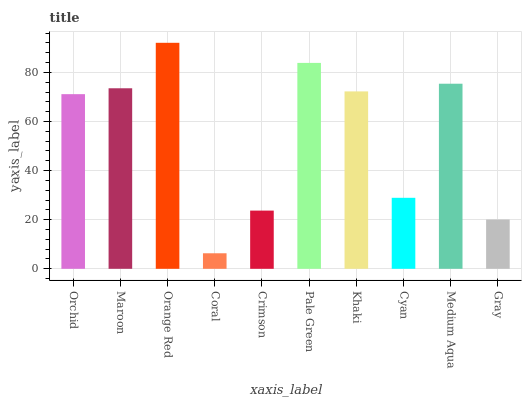Is Coral the minimum?
Answer yes or no. Yes. Is Orange Red the maximum?
Answer yes or no. Yes. Is Maroon the minimum?
Answer yes or no. No. Is Maroon the maximum?
Answer yes or no. No. Is Maroon greater than Orchid?
Answer yes or no. Yes. Is Orchid less than Maroon?
Answer yes or no. Yes. Is Orchid greater than Maroon?
Answer yes or no. No. Is Maroon less than Orchid?
Answer yes or no. No. Is Khaki the high median?
Answer yes or no. Yes. Is Orchid the low median?
Answer yes or no. Yes. Is Orange Red the high median?
Answer yes or no. No. Is Orange Red the low median?
Answer yes or no. No. 